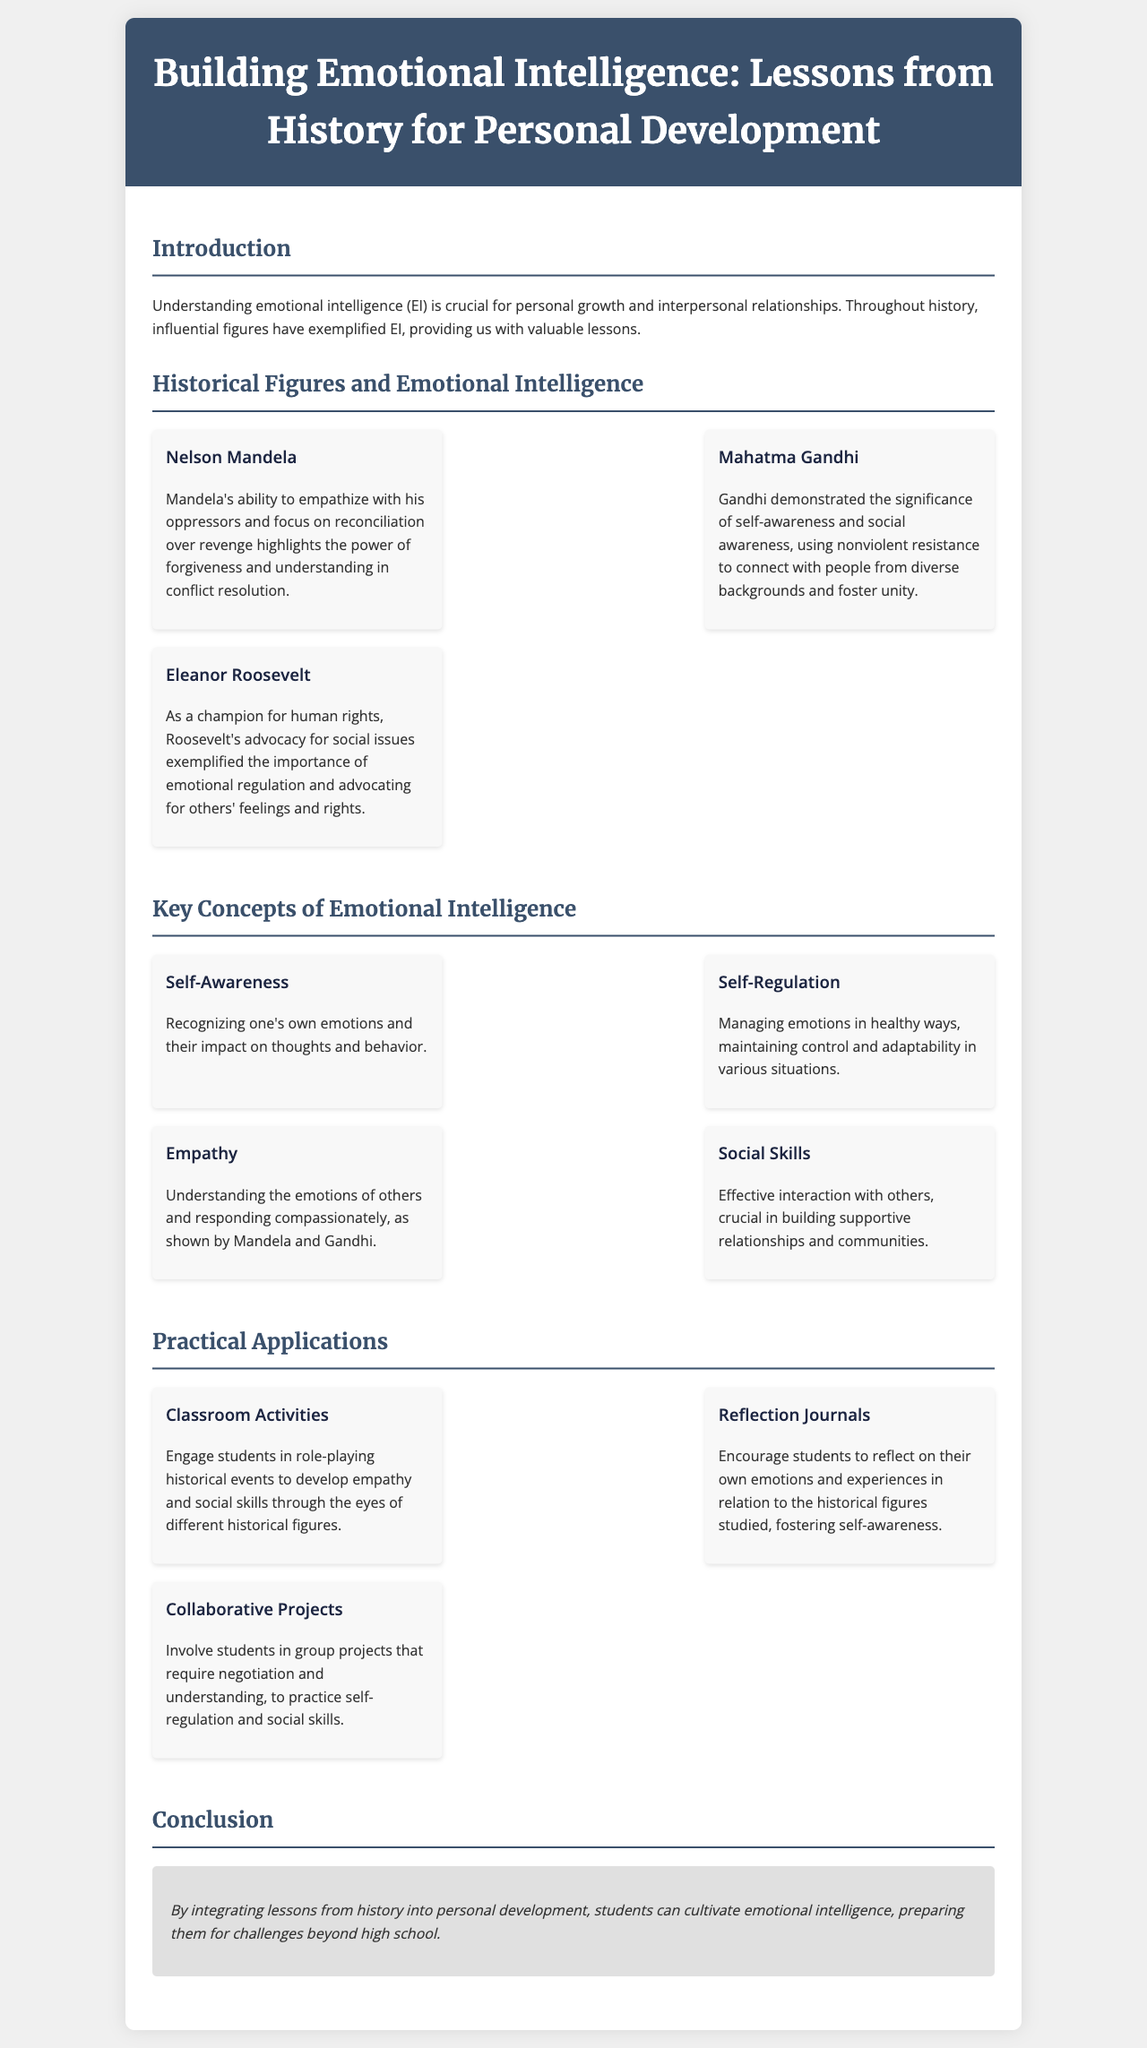What is the title of the brochure? The title of the brochure is in the header section, which states the focus of the document.
Answer: Building Emotional Intelligence: Lessons from History for Personal Development Who is featured as a historical figure known for empathy? The brochure highlights historical figures, including those recognized for their emotional intelligence qualities.
Answer: Nelson Mandela What is one key concept of emotional intelligence mentioned? The brochure lists several key concepts, showcasing fundamental aspects of emotional intelligence.
Answer: Self-Awareness How many practical applications are provided in the brochure? The document contains a section detailing practical applications, which includes specific activities for students.
Answer: Three What was Eleanor Roosevelt known for according to the brochure? The brochure describes specific qualities and contributions of historical figures related to emotional intelligence.
Answer: Advocacy for human rights How does the brochure suggest developing empathy in students? The brochure provides a specific classroom activity designed to enhance emotional intelligence skills among students.
Answer: Role-playing historical events What is the main goal mentioned in the conclusion of the brochure? The conclusion summarizes the overarching purpose of the content presented in the brochure.
Answer: Cultivating emotional intelligence Which historical figure is associated with nonviolent resistance? The document provides information about historical figures and their notable contributions to social movements.
Answer: Mahatma Gandhi 